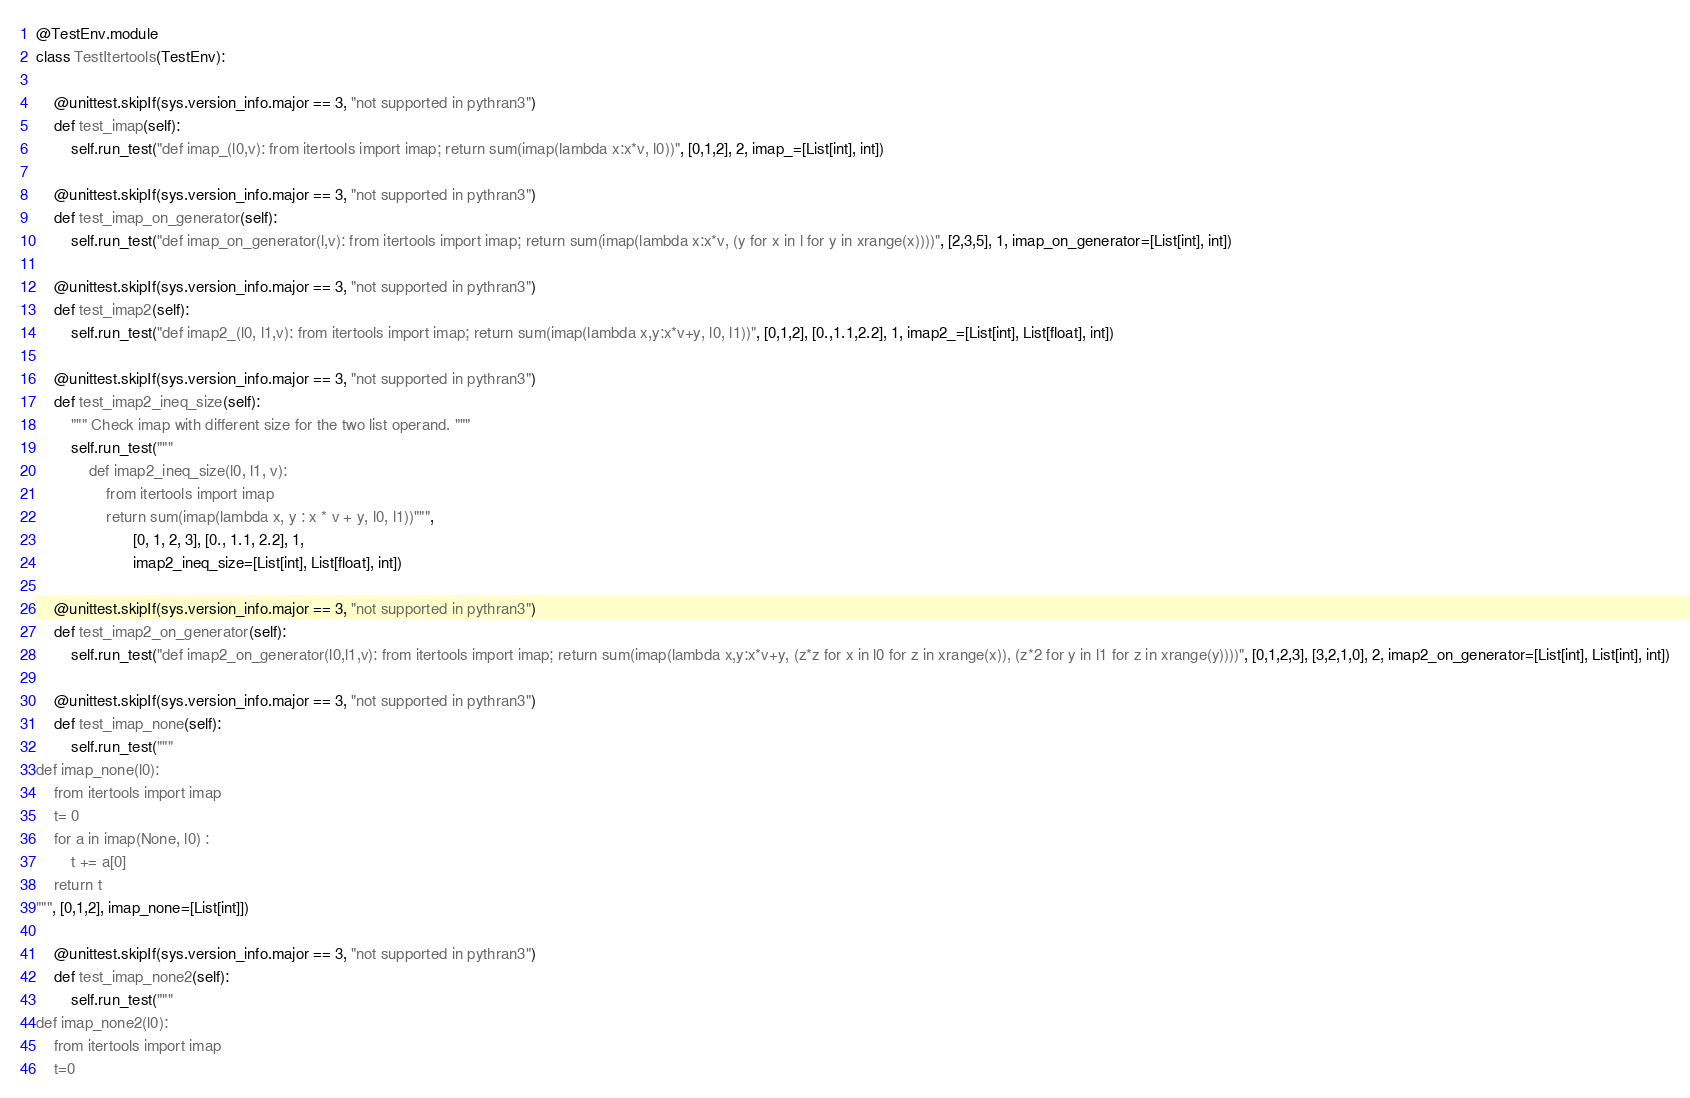<code> <loc_0><loc_0><loc_500><loc_500><_Python_>@TestEnv.module
class TestItertools(TestEnv):

    @unittest.skipIf(sys.version_info.major == 3, "not supported in pythran3")
    def test_imap(self):
        self.run_test("def imap_(l0,v): from itertools import imap; return sum(imap(lambda x:x*v, l0))", [0,1,2], 2, imap_=[List[int], int])

    @unittest.skipIf(sys.version_info.major == 3, "not supported in pythran3")
    def test_imap_on_generator(self):
        self.run_test("def imap_on_generator(l,v): from itertools import imap; return sum(imap(lambda x:x*v, (y for x in l for y in xrange(x))))", [2,3,5], 1, imap_on_generator=[List[int], int])

    @unittest.skipIf(sys.version_info.major == 3, "not supported in pythran3")
    def test_imap2(self):
        self.run_test("def imap2_(l0, l1,v): from itertools import imap; return sum(imap(lambda x,y:x*v+y, l0, l1))", [0,1,2], [0.,1.1,2.2], 1, imap2_=[List[int], List[float], int])

    @unittest.skipIf(sys.version_info.major == 3, "not supported in pythran3")
    def test_imap2_ineq_size(self):
        """ Check imap with different size for the two list operand. """
        self.run_test("""
            def imap2_ineq_size(l0, l1, v):
                from itertools import imap
                return sum(imap(lambda x, y : x * v + y, l0, l1))""",
                      [0, 1, 2, 3], [0., 1.1, 2.2], 1,
                      imap2_ineq_size=[List[int], List[float], int])

    @unittest.skipIf(sys.version_info.major == 3, "not supported in pythran3")
    def test_imap2_on_generator(self):
        self.run_test("def imap2_on_generator(l0,l1,v): from itertools import imap; return sum(imap(lambda x,y:x*v+y, (z*z for x in l0 for z in xrange(x)), (z*2 for y in l1 for z in xrange(y))))", [0,1,2,3], [3,2,1,0], 2, imap2_on_generator=[List[int], List[int], int])

    @unittest.skipIf(sys.version_info.major == 3, "not supported in pythran3")
    def test_imap_none(self):
        self.run_test("""
def imap_none(l0):
    from itertools import imap
    t= 0
    for a in imap(None, l0) :
        t += a[0]
    return t
""", [0,1,2], imap_none=[List[int]])

    @unittest.skipIf(sys.version_info.major == 3, "not supported in pythran3")
    def test_imap_none2(self):
        self.run_test("""
def imap_none2(l0):
    from itertools import imap
    t=0</code> 